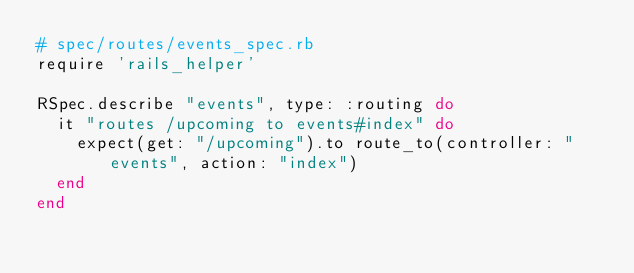Convert code to text. <code><loc_0><loc_0><loc_500><loc_500><_Ruby_># spec/routes/events_spec.rb
require 'rails_helper'

RSpec.describe "events", type: :routing do
  it "routes /upcoming to events#index" do
    expect(get: "/upcoming").to route_to(controller: "events", action: "index")
  end
end</code> 